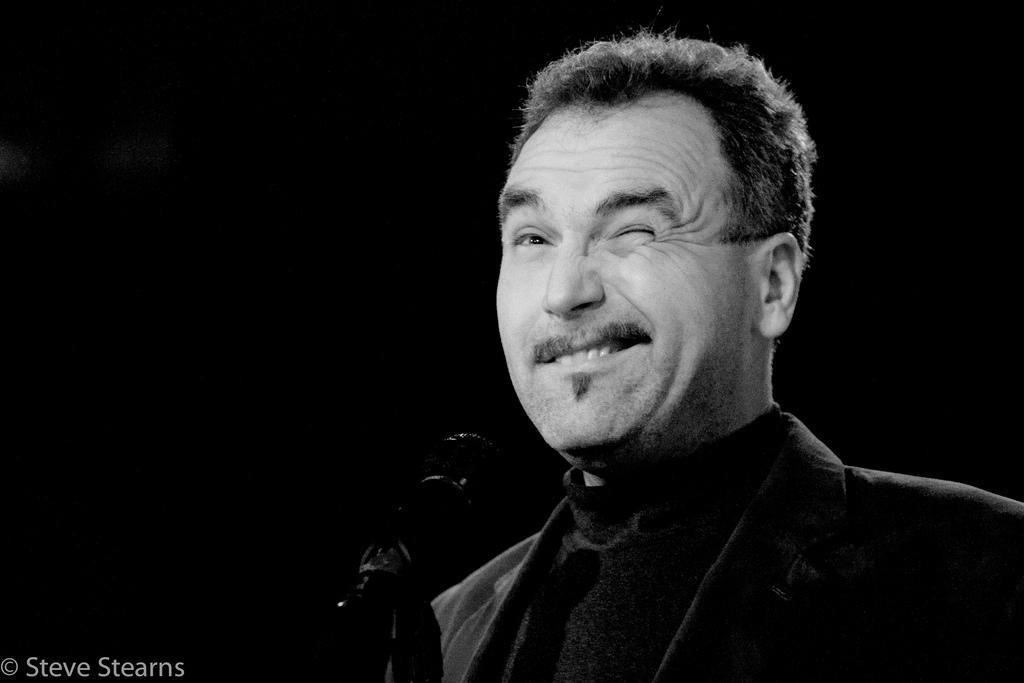In one or two sentences, can you explain what this image depicts? In this image there is a man. He is winking. There is a microphone in front of him. The background is dark. In the bottom left there is text on image. 